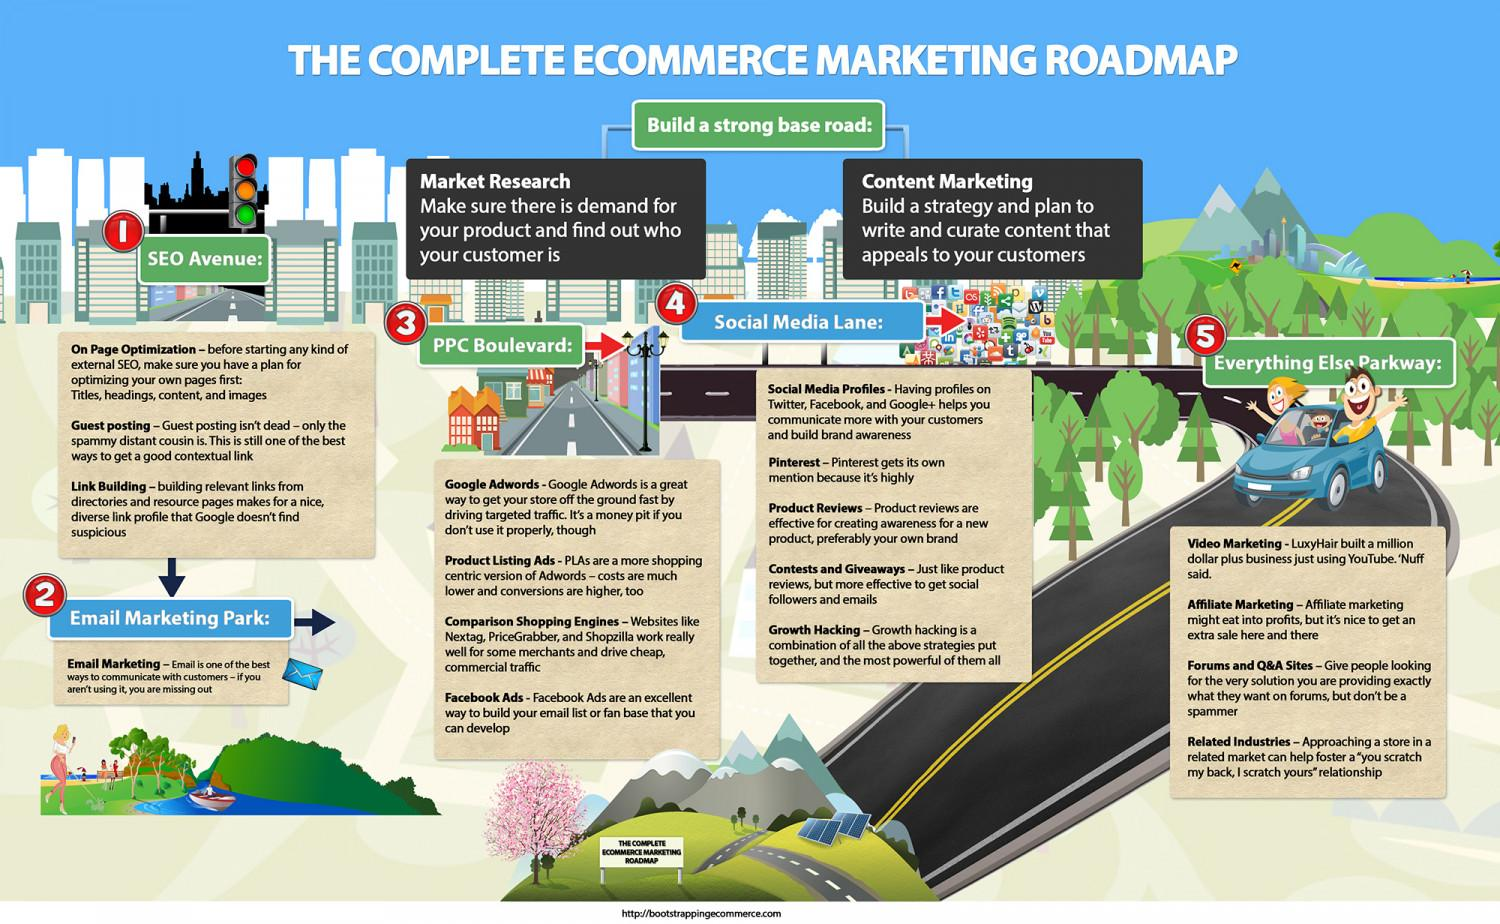Point out several critical features in this image. The act of developing and implementing a strategy, and creating content that is tailored to appeal to our customers, is known as content marketing. One effective way to acquire social followers and emails is through the use of contests and giveaways. Product reviews are effective in creating awareness about products and brands. YouTube can be used in the field of video marketing. The use of Google AdWords is an effective method for driving targeted traffic to a website. 